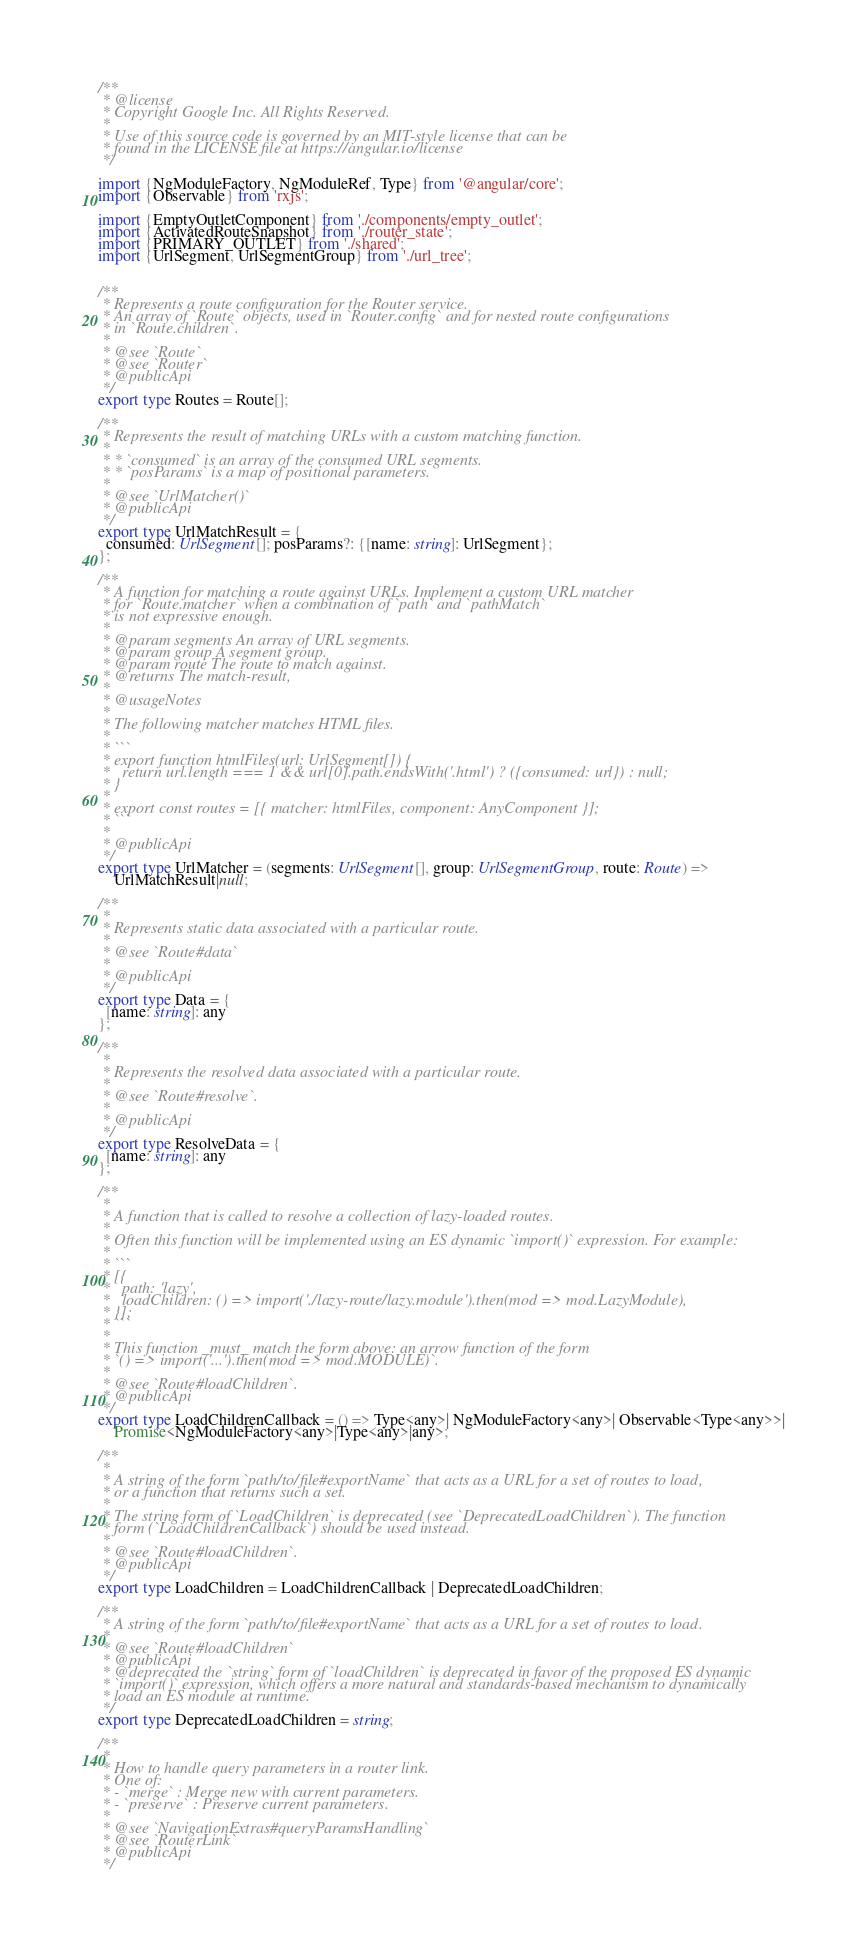Convert code to text. <code><loc_0><loc_0><loc_500><loc_500><_TypeScript_>/**
 * @license
 * Copyright Google Inc. All Rights Reserved.
 *
 * Use of this source code is governed by an MIT-style license that can be
 * found in the LICENSE file at https://angular.io/license
 */

import {NgModuleFactory, NgModuleRef, Type} from '@angular/core';
import {Observable} from 'rxjs';

import {EmptyOutletComponent} from './components/empty_outlet';
import {ActivatedRouteSnapshot} from './router_state';
import {PRIMARY_OUTLET} from './shared';
import {UrlSegment, UrlSegmentGroup} from './url_tree';


/**
 * Represents a route configuration for the Router service.
 * An array of `Route` objects, used in `Router.config` and for nested route configurations
 * in `Route.children`.
 *
 * @see `Route`
 * @see `Router`
 * @publicApi
 */
export type Routes = Route[];

/**
 * Represents the result of matching URLs with a custom matching function.
 *
 * * `consumed` is an array of the consumed URL segments.
 * * `posParams` is a map of positional parameters.
 *
 * @see `UrlMatcher()`
 * @publicApi
 */
export type UrlMatchResult = {
  consumed: UrlSegment[]; posParams?: {[name: string]: UrlSegment};
};

/**
 * A function for matching a route against URLs. Implement a custom URL matcher
 * for `Route.matcher` when a combination of `path` and `pathMatch`
 * is not expressive enough.
 *
 * @param segments An array of URL segments.
 * @param group A segment group.
 * @param route The route to match against.
 * @returns The match-result,
 *
 * @usageNotes
 *
 * The following matcher matches HTML files.
 *
 * ```
 * export function htmlFiles(url: UrlSegment[]) {
 *   return url.length === 1 && url[0].path.endsWith('.html') ? ({consumed: url}) : null;
 * }
 *
 * export const routes = [{ matcher: htmlFiles, component: AnyComponent }];
 * ```
 *
 * @publicApi
 */
export type UrlMatcher = (segments: UrlSegment[], group: UrlSegmentGroup, route: Route) =>
    UrlMatchResult|null;

/**
 *
 * Represents static data associated with a particular route.
 *
 * @see `Route#data`
 *
 * @publicApi
 */
export type Data = {
  [name: string]: any
};

/**
 *
 * Represents the resolved data associated with a particular route.
 *
 * @see `Route#resolve`.
 *
 * @publicApi
 */
export type ResolveData = {
  [name: string]: any
};

/**
 *
 * A function that is called to resolve a collection of lazy-loaded routes.
 *
 * Often this function will be implemented using an ES dynamic `import()` expression. For example:
 *
 * ```
 * [{
 *   path: 'lazy',
 *   loadChildren: () => import('./lazy-route/lazy.module').then(mod => mod.LazyModule),
 * }];
 * ```
 *
 * This function _must_ match the form above: an arrow function of the form
 * `() => import('...').then(mod => mod.MODULE)`.
 *
 * @see `Route#loadChildren`.
 * @publicApi
 */
export type LoadChildrenCallback = () => Type<any>| NgModuleFactory<any>| Observable<Type<any>>|
    Promise<NgModuleFactory<any>|Type<any>|any>;

/**
 *
 * A string of the form `path/to/file#exportName` that acts as a URL for a set of routes to load,
 * or a function that returns such a set.
 *
 * The string form of `LoadChildren` is deprecated (see `DeprecatedLoadChildren`). The function
 * form (`LoadChildrenCallback`) should be used instead.
 *
 * @see `Route#loadChildren`.
 * @publicApi
 */
export type LoadChildren = LoadChildrenCallback | DeprecatedLoadChildren;

/**
 * A string of the form `path/to/file#exportName` that acts as a URL for a set of routes to load.
 *
 * @see `Route#loadChildren`
 * @publicApi
 * @deprecated the `string` form of `loadChildren` is deprecated in favor of the proposed ES dynamic
 * `import()` expression, which offers a more natural and standards-based mechanism to dynamically
 * load an ES module at runtime.
 */
export type DeprecatedLoadChildren = string;

/**
 *
 * How to handle query parameters in a router link.
 * One of:
 * - `merge` : Merge new with current parameters.
 * - `preserve` : Preserve current parameters.
 *
 * @see `NavigationExtras#queryParamsHandling`
 * @see `RouterLink`
 * @publicApi
 */</code> 